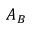<formula> <loc_0><loc_0><loc_500><loc_500>A _ { B }</formula> 